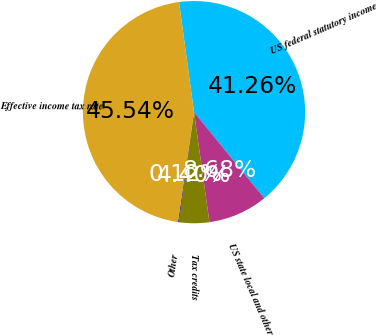Convert chart. <chart><loc_0><loc_0><loc_500><loc_500><pie_chart><fcel>US federal statutory income<fcel>US state local and other<fcel>Tax credits<fcel>Other<fcel>Effective income tax rate<nl><fcel>41.26%<fcel>8.68%<fcel>4.4%<fcel>0.12%<fcel>45.54%<nl></chart> 